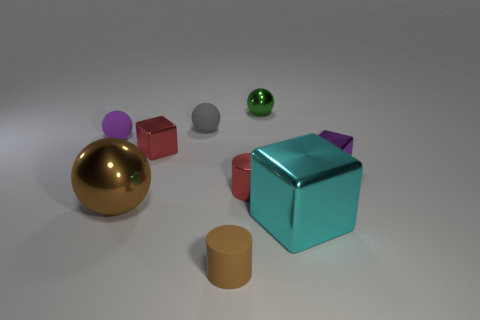There is a purple rubber thing that is the same size as the brown cylinder; what shape is it?
Your answer should be very brief. Sphere. Are there any tiny purple metallic things of the same shape as the cyan metallic object?
Offer a very short reply. Yes. What is the shape of the tiny purple object that is on the right side of the big metal thing to the left of the big cube?
Offer a very short reply. Cube. What is the shape of the tiny green object?
Make the answer very short. Sphere. What is the material of the large thing right of the small metal object that is behind the tiny purple object to the left of the tiny purple shiny cube?
Offer a terse response. Metal. What number of other things are there of the same material as the small brown cylinder
Your response must be concise. 2. There is a purple thing that is to the right of the small green shiny object; how many cyan metallic things are behind it?
Offer a terse response. 0. How many cylinders are either small gray rubber things or green metal things?
Ensure brevity in your answer.  0. What is the color of the metallic cube that is behind the large shiny block and in front of the small red cube?
Offer a terse response. Purple. Is there any other thing of the same color as the tiny shiny cylinder?
Provide a succinct answer. Yes. 